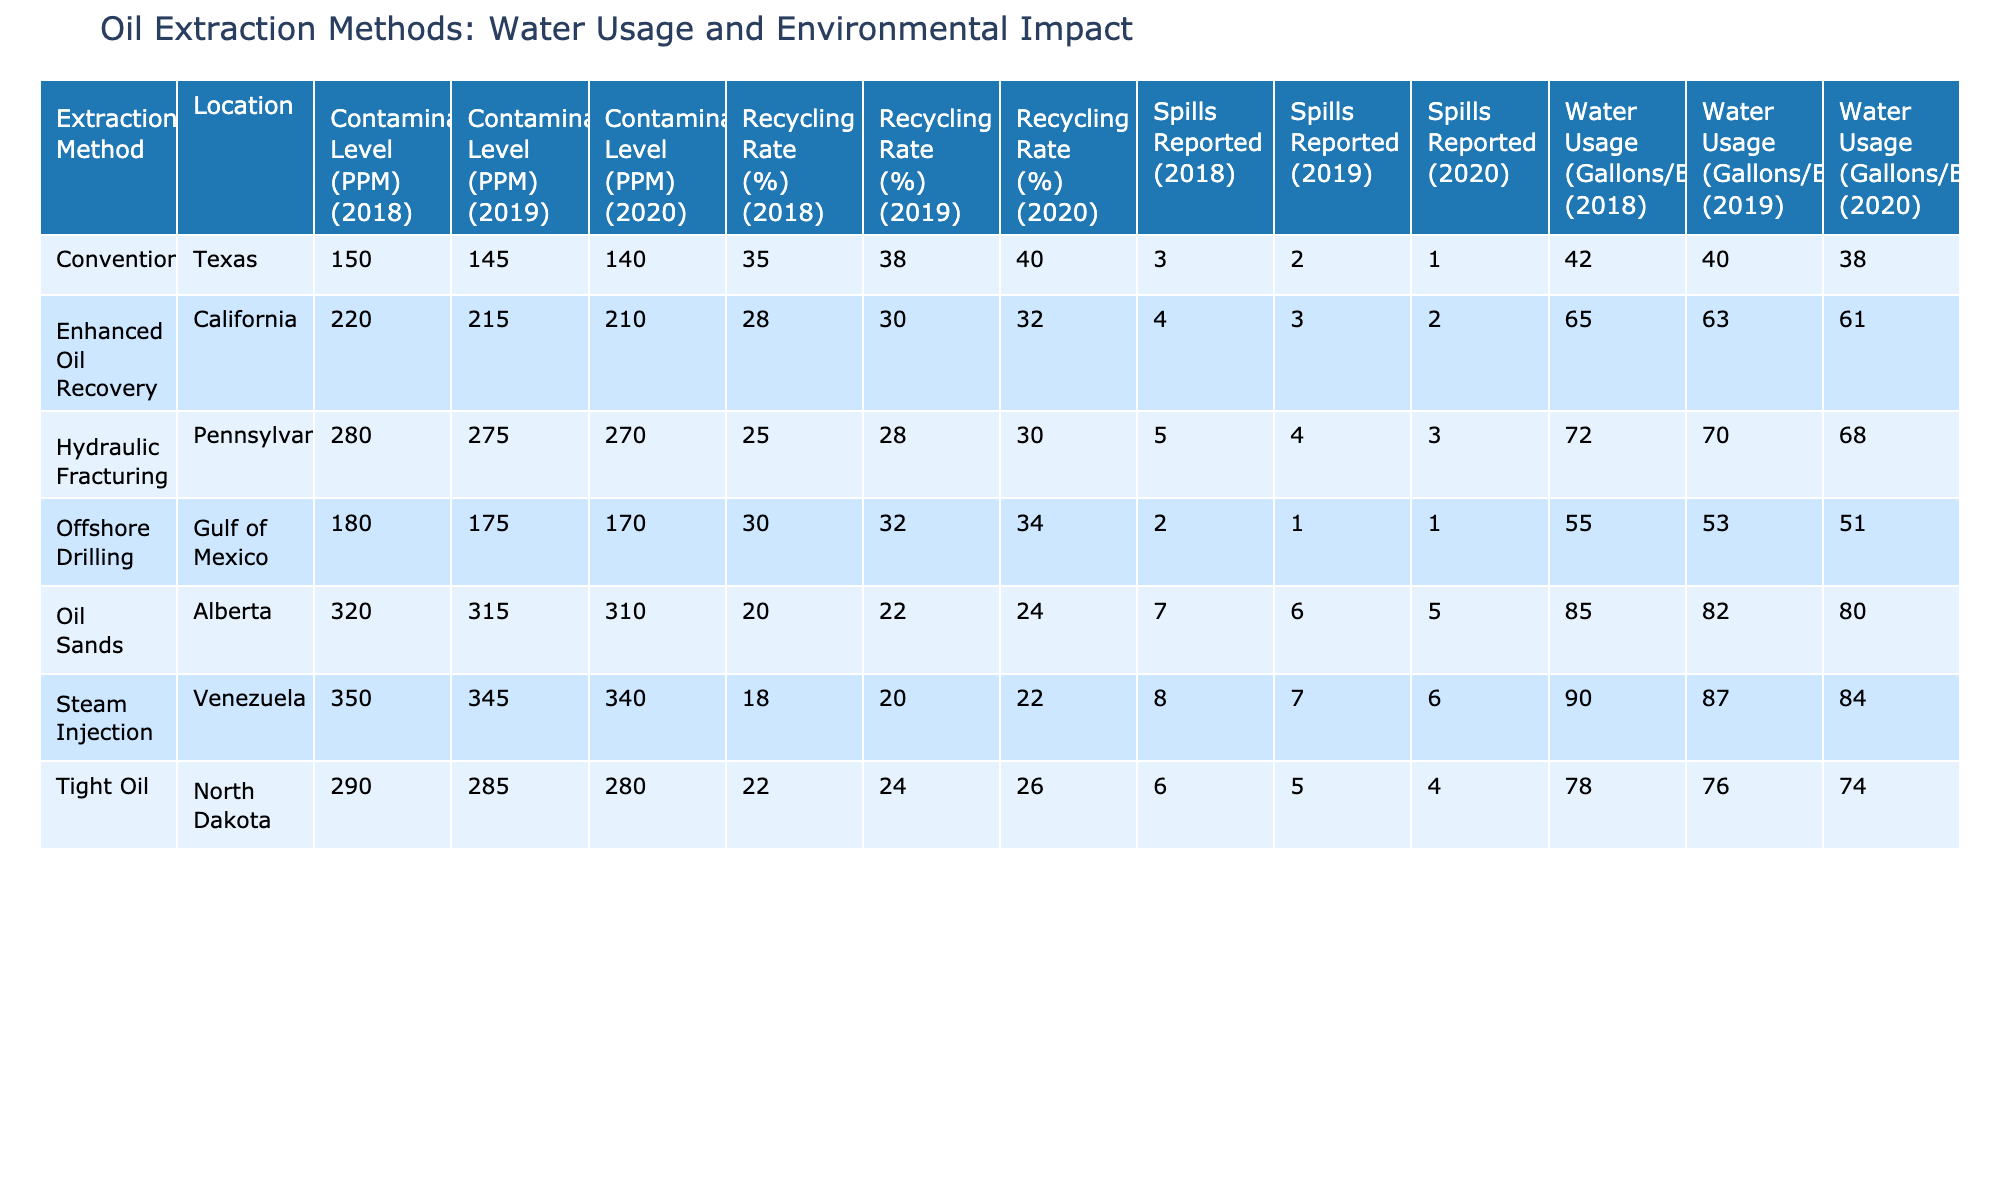What is the highest water usage per barrel among all extraction methods in 2018? The highest water usage per barrel in 2018 can be found by examining the Water Usage (Gallons/Barrel) for each extraction method in that year. The maximum value is 90 gallons per barrel from the Steam Injection method in Venezuela.
Answer: 90 Which extraction method had the lowest recycling rate in 2019? By looking at the Recycling Rate (%) for each method in 2019, the lowest value is 18% from the Steam Injection method in Venezuela.
Answer: 18 How many spills were reported in total for Hydraulic Fracturing across all years? To find the total spills reported, sum the Spills Reported values for Hydraulic Fracturing across all recorded years: 5 (2018) + 4 (2019) + 3 (2020) = 12 spills in total.
Answer: 12 What is the average contamination level (PPM) for Oil Sands across all years? The average contamination level for Oil Sands can be calculated by adding the contamination levels for each year: (320 + 315 + 310) = 945, and then dividing by the number of years (3) to get an average of 315 PPM.
Answer: 315 Was the contamination level higher in Offshore Drilling in 2020 compared to Conventional extraction in the same year? For Offshore Drilling in 2020, the contamination level is 170 PPM, while for Conventional extraction in 2020, it is 140 PPM. Since 170 is greater than 140, the statement is true.
Answer: Yes Is the water usage per barrel in Enhanced Oil Recovery declining from 2018 to 2020? Reviewing the Water Usage values, Enhanced Oil Recovery started with 65 gallons per barrel in 2018, decreased to 63 in 2019, and further decreased to 61 in 2020, indicating a consistent decline in water usage.
Answer: Yes What extraction method showed the highest contamination level on average across all years? Calculate the average contamination level for each extraction method. For instance, Oil Sands: (320 + 315 + 310) / 3 = 315, Hydraulic Fracturing: (280 + 275 + 270) / 3 = 275, and so on. The highest average among these methods is Oil Sands with an average of 315 PPM.
Answer: Oil Sands How does the average water usage of Tight Oil compare to Offshore Drilling over the three years? Calculate the averages: Tight Oil uses (78 + 76 + 74) / 3 = 76 gallons per barrel, while Offshore Drilling uses (55 + 53 + 51) / 3 = 53 gallons per barrel. The average water usage for Tight Oil is higher than that for Offshore Drilling.
Answer: Tight Oil is higher What was the total water usage for Oil Sands in 2019? To find total water usage for Oil Sands in 2019, refer to the water usage per barrel value in that year, which is 82 gallons, and then since there is 1 report of usage (as it is the same company), the total remains 82 gallons in context of this table.
Answer: 82 